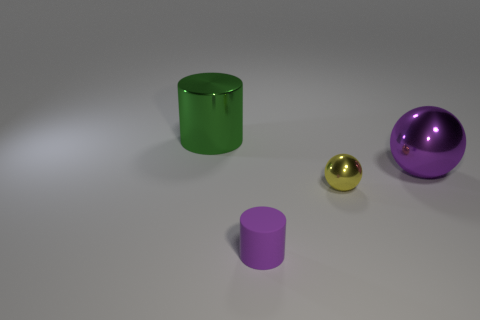There is a cylinder that is on the left side of the purple rubber cylinder; is its color the same as the small object right of the tiny purple object?
Provide a short and direct response. No. Is the material of the object that is in front of the tiny metal sphere the same as the green cylinder behind the big ball?
Offer a terse response. No. How many purple rubber things are the same size as the green cylinder?
Offer a very short reply. 0. Is the number of small purple metallic balls less than the number of objects?
Keep it short and to the point. Yes. There is a thing behind the purple object behind the small ball; what is its shape?
Offer a terse response. Cylinder. There is a matte object that is the same size as the yellow ball; what is its shape?
Offer a terse response. Cylinder. Are there any large green objects of the same shape as the yellow shiny object?
Keep it short and to the point. No. What is the green thing made of?
Offer a terse response. Metal. Are there any big green shiny objects in front of the purple matte cylinder?
Offer a terse response. No. There is a metallic object left of the tiny ball; what number of large green shiny cylinders are behind it?
Provide a succinct answer. 0. 